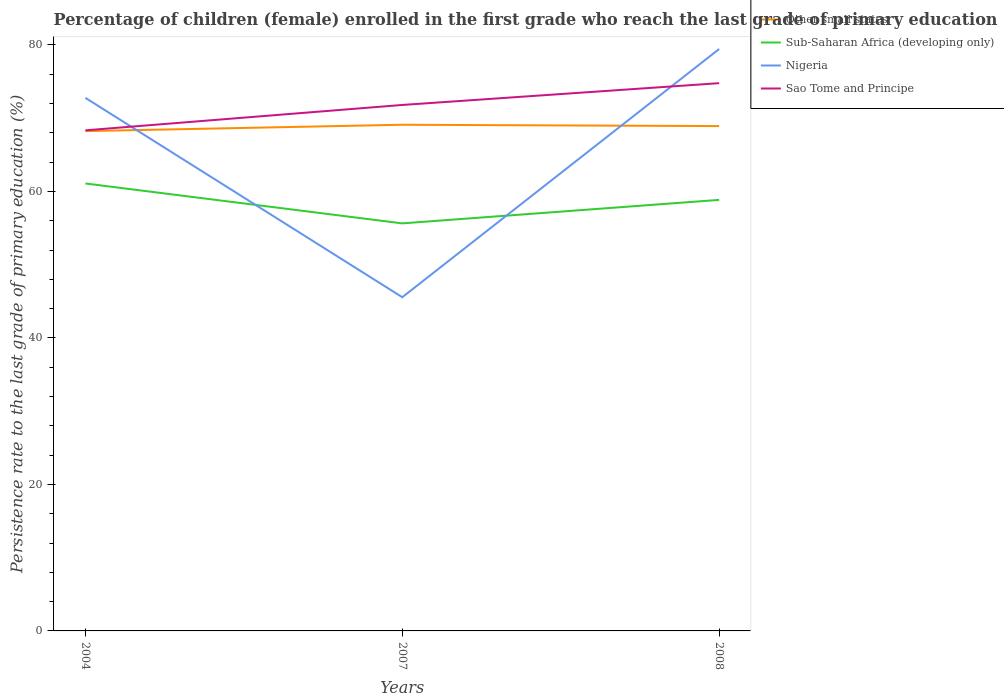Across all years, what is the maximum persistence rate of children in Sub-Saharan Africa (developing only)?
Give a very brief answer. 55.64. What is the total persistence rate of children in Sub-Saharan Africa (developing only) in the graph?
Provide a short and direct response. 5.45. What is the difference between the highest and the second highest persistence rate of children in Sao Tome and Principe?
Provide a short and direct response. 6.44. What is the difference between the highest and the lowest persistence rate of children in Sub-Saharan Africa (developing only)?
Offer a very short reply. 2. Is the persistence rate of children in Sub-Saharan Africa (developing only) strictly greater than the persistence rate of children in Nigeria over the years?
Keep it short and to the point. No. What is the difference between two consecutive major ticks on the Y-axis?
Your answer should be compact. 20. What is the title of the graph?
Your answer should be compact. Percentage of children (female) enrolled in the first grade who reach the last grade of primary education. Does "St. Lucia" appear as one of the legend labels in the graph?
Provide a short and direct response. No. What is the label or title of the X-axis?
Offer a terse response. Years. What is the label or title of the Y-axis?
Offer a very short reply. Persistence rate to the last grade of primary education (%). What is the Persistence rate to the last grade of primary education (%) of Other small states in 2004?
Give a very brief answer. 68.23. What is the Persistence rate to the last grade of primary education (%) of Sub-Saharan Africa (developing only) in 2004?
Give a very brief answer. 61.08. What is the Persistence rate to the last grade of primary education (%) in Nigeria in 2004?
Give a very brief answer. 72.77. What is the Persistence rate to the last grade of primary education (%) in Sao Tome and Principe in 2004?
Your answer should be very brief. 68.34. What is the Persistence rate to the last grade of primary education (%) of Other small states in 2007?
Keep it short and to the point. 69.1. What is the Persistence rate to the last grade of primary education (%) of Sub-Saharan Africa (developing only) in 2007?
Keep it short and to the point. 55.64. What is the Persistence rate to the last grade of primary education (%) of Nigeria in 2007?
Your answer should be very brief. 45.56. What is the Persistence rate to the last grade of primary education (%) in Sao Tome and Principe in 2007?
Your answer should be compact. 71.8. What is the Persistence rate to the last grade of primary education (%) in Other small states in 2008?
Offer a very short reply. 68.92. What is the Persistence rate to the last grade of primary education (%) of Sub-Saharan Africa (developing only) in 2008?
Provide a succinct answer. 58.85. What is the Persistence rate to the last grade of primary education (%) of Nigeria in 2008?
Provide a short and direct response. 79.44. What is the Persistence rate to the last grade of primary education (%) in Sao Tome and Principe in 2008?
Provide a short and direct response. 74.78. Across all years, what is the maximum Persistence rate to the last grade of primary education (%) in Other small states?
Offer a very short reply. 69.1. Across all years, what is the maximum Persistence rate to the last grade of primary education (%) of Sub-Saharan Africa (developing only)?
Provide a succinct answer. 61.08. Across all years, what is the maximum Persistence rate to the last grade of primary education (%) in Nigeria?
Make the answer very short. 79.44. Across all years, what is the maximum Persistence rate to the last grade of primary education (%) in Sao Tome and Principe?
Offer a terse response. 74.78. Across all years, what is the minimum Persistence rate to the last grade of primary education (%) in Other small states?
Your answer should be compact. 68.23. Across all years, what is the minimum Persistence rate to the last grade of primary education (%) in Sub-Saharan Africa (developing only)?
Offer a very short reply. 55.64. Across all years, what is the minimum Persistence rate to the last grade of primary education (%) of Nigeria?
Your response must be concise. 45.56. Across all years, what is the minimum Persistence rate to the last grade of primary education (%) of Sao Tome and Principe?
Offer a very short reply. 68.34. What is the total Persistence rate to the last grade of primary education (%) in Other small states in the graph?
Make the answer very short. 206.25. What is the total Persistence rate to the last grade of primary education (%) of Sub-Saharan Africa (developing only) in the graph?
Provide a succinct answer. 175.57. What is the total Persistence rate to the last grade of primary education (%) in Nigeria in the graph?
Your answer should be very brief. 197.77. What is the total Persistence rate to the last grade of primary education (%) in Sao Tome and Principe in the graph?
Your answer should be very brief. 214.93. What is the difference between the Persistence rate to the last grade of primary education (%) in Other small states in 2004 and that in 2007?
Provide a succinct answer. -0.87. What is the difference between the Persistence rate to the last grade of primary education (%) of Sub-Saharan Africa (developing only) in 2004 and that in 2007?
Your response must be concise. 5.45. What is the difference between the Persistence rate to the last grade of primary education (%) in Nigeria in 2004 and that in 2007?
Offer a terse response. 27.21. What is the difference between the Persistence rate to the last grade of primary education (%) of Sao Tome and Principe in 2004 and that in 2007?
Your response must be concise. -3.46. What is the difference between the Persistence rate to the last grade of primary education (%) of Other small states in 2004 and that in 2008?
Your response must be concise. -0.69. What is the difference between the Persistence rate to the last grade of primary education (%) of Sub-Saharan Africa (developing only) in 2004 and that in 2008?
Make the answer very short. 2.24. What is the difference between the Persistence rate to the last grade of primary education (%) in Nigeria in 2004 and that in 2008?
Make the answer very short. -6.67. What is the difference between the Persistence rate to the last grade of primary education (%) in Sao Tome and Principe in 2004 and that in 2008?
Ensure brevity in your answer.  -6.44. What is the difference between the Persistence rate to the last grade of primary education (%) of Other small states in 2007 and that in 2008?
Your answer should be compact. 0.18. What is the difference between the Persistence rate to the last grade of primary education (%) in Sub-Saharan Africa (developing only) in 2007 and that in 2008?
Give a very brief answer. -3.21. What is the difference between the Persistence rate to the last grade of primary education (%) in Nigeria in 2007 and that in 2008?
Make the answer very short. -33.89. What is the difference between the Persistence rate to the last grade of primary education (%) in Sao Tome and Principe in 2007 and that in 2008?
Ensure brevity in your answer.  -2.98. What is the difference between the Persistence rate to the last grade of primary education (%) in Other small states in 2004 and the Persistence rate to the last grade of primary education (%) in Sub-Saharan Africa (developing only) in 2007?
Give a very brief answer. 12.59. What is the difference between the Persistence rate to the last grade of primary education (%) in Other small states in 2004 and the Persistence rate to the last grade of primary education (%) in Nigeria in 2007?
Provide a succinct answer. 22.67. What is the difference between the Persistence rate to the last grade of primary education (%) in Other small states in 2004 and the Persistence rate to the last grade of primary education (%) in Sao Tome and Principe in 2007?
Keep it short and to the point. -3.57. What is the difference between the Persistence rate to the last grade of primary education (%) in Sub-Saharan Africa (developing only) in 2004 and the Persistence rate to the last grade of primary education (%) in Nigeria in 2007?
Make the answer very short. 15.53. What is the difference between the Persistence rate to the last grade of primary education (%) of Sub-Saharan Africa (developing only) in 2004 and the Persistence rate to the last grade of primary education (%) of Sao Tome and Principe in 2007?
Provide a short and direct response. -10.72. What is the difference between the Persistence rate to the last grade of primary education (%) in Nigeria in 2004 and the Persistence rate to the last grade of primary education (%) in Sao Tome and Principe in 2007?
Offer a very short reply. 0.97. What is the difference between the Persistence rate to the last grade of primary education (%) in Other small states in 2004 and the Persistence rate to the last grade of primary education (%) in Sub-Saharan Africa (developing only) in 2008?
Ensure brevity in your answer.  9.39. What is the difference between the Persistence rate to the last grade of primary education (%) in Other small states in 2004 and the Persistence rate to the last grade of primary education (%) in Nigeria in 2008?
Your answer should be compact. -11.21. What is the difference between the Persistence rate to the last grade of primary education (%) in Other small states in 2004 and the Persistence rate to the last grade of primary education (%) in Sao Tome and Principe in 2008?
Provide a short and direct response. -6.55. What is the difference between the Persistence rate to the last grade of primary education (%) of Sub-Saharan Africa (developing only) in 2004 and the Persistence rate to the last grade of primary education (%) of Nigeria in 2008?
Your answer should be compact. -18.36. What is the difference between the Persistence rate to the last grade of primary education (%) in Sub-Saharan Africa (developing only) in 2004 and the Persistence rate to the last grade of primary education (%) in Sao Tome and Principe in 2008?
Your response must be concise. -13.69. What is the difference between the Persistence rate to the last grade of primary education (%) in Nigeria in 2004 and the Persistence rate to the last grade of primary education (%) in Sao Tome and Principe in 2008?
Provide a short and direct response. -2.01. What is the difference between the Persistence rate to the last grade of primary education (%) in Other small states in 2007 and the Persistence rate to the last grade of primary education (%) in Sub-Saharan Africa (developing only) in 2008?
Offer a very short reply. 10.26. What is the difference between the Persistence rate to the last grade of primary education (%) in Other small states in 2007 and the Persistence rate to the last grade of primary education (%) in Nigeria in 2008?
Your response must be concise. -10.34. What is the difference between the Persistence rate to the last grade of primary education (%) in Other small states in 2007 and the Persistence rate to the last grade of primary education (%) in Sao Tome and Principe in 2008?
Make the answer very short. -5.68. What is the difference between the Persistence rate to the last grade of primary education (%) of Sub-Saharan Africa (developing only) in 2007 and the Persistence rate to the last grade of primary education (%) of Nigeria in 2008?
Your answer should be very brief. -23.81. What is the difference between the Persistence rate to the last grade of primary education (%) in Sub-Saharan Africa (developing only) in 2007 and the Persistence rate to the last grade of primary education (%) in Sao Tome and Principe in 2008?
Offer a terse response. -19.14. What is the difference between the Persistence rate to the last grade of primary education (%) in Nigeria in 2007 and the Persistence rate to the last grade of primary education (%) in Sao Tome and Principe in 2008?
Ensure brevity in your answer.  -29.22. What is the average Persistence rate to the last grade of primary education (%) of Other small states per year?
Keep it short and to the point. 68.75. What is the average Persistence rate to the last grade of primary education (%) of Sub-Saharan Africa (developing only) per year?
Keep it short and to the point. 58.52. What is the average Persistence rate to the last grade of primary education (%) in Nigeria per year?
Your response must be concise. 65.92. What is the average Persistence rate to the last grade of primary education (%) in Sao Tome and Principe per year?
Make the answer very short. 71.64. In the year 2004, what is the difference between the Persistence rate to the last grade of primary education (%) in Other small states and Persistence rate to the last grade of primary education (%) in Sub-Saharan Africa (developing only)?
Offer a terse response. 7.15. In the year 2004, what is the difference between the Persistence rate to the last grade of primary education (%) of Other small states and Persistence rate to the last grade of primary education (%) of Nigeria?
Give a very brief answer. -4.54. In the year 2004, what is the difference between the Persistence rate to the last grade of primary education (%) of Other small states and Persistence rate to the last grade of primary education (%) of Sao Tome and Principe?
Ensure brevity in your answer.  -0.11. In the year 2004, what is the difference between the Persistence rate to the last grade of primary education (%) of Sub-Saharan Africa (developing only) and Persistence rate to the last grade of primary education (%) of Nigeria?
Provide a succinct answer. -11.69. In the year 2004, what is the difference between the Persistence rate to the last grade of primary education (%) of Sub-Saharan Africa (developing only) and Persistence rate to the last grade of primary education (%) of Sao Tome and Principe?
Provide a short and direct response. -7.26. In the year 2004, what is the difference between the Persistence rate to the last grade of primary education (%) in Nigeria and Persistence rate to the last grade of primary education (%) in Sao Tome and Principe?
Your answer should be compact. 4.43. In the year 2007, what is the difference between the Persistence rate to the last grade of primary education (%) in Other small states and Persistence rate to the last grade of primary education (%) in Sub-Saharan Africa (developing only)?
Offer a very short reply. 13.46. In the year 2007, what is the difference between the Persistence rate to the last grade of primary education (%) in Other small states and Persistence rate to the last grade of primary education (%) in Nigeria?
Provide a succinct answer. 23.54. In the year 2007, what is the difference between the Persistence rate to the last grade of primary education (%) of Other small states and Persistence rate to the last grade of primary education (%) of Sao Tome and Principe?
Your answer should be very brief. -2.7. In the year 2007, what is the difference between the Persistence rate to the last grade of primary education (%) in Sub-Saharan Africa (developing only) and Persistence rate to the last grade of primary education (%) in Nigeria?
Provide a succinct answer. 10.08. In the year 2007, what is the difference between the Persistence rate to the last grade of primary education (%) in Sub-Saharan Africa (developing only) and Persistence rate to the last grade of primary education (%) in Sao Tome and Principe?
Make the answer very short. -16.17. In the year 2007, what is the difference between the Persistence rate to the last grade of primary education (%) in Nigeria and Persistence rate to the last grade of primary education (%) in Sao Tome and Principe?
Your response must be concise. -26.25. In the year 2008, what is the difference between the Persistence rate to the last grade of primary education (%) in Other small states and Persistence rate to the last grade of primary education (%) in Sub-Saharan Africa (developing only)?
Provide a short and direct response. 10.07. In the year 2008, what is the difference between the Persistence rate to the last grade of primary education (%) of Other small states and Persistence rate to the last grade of primary education (%) of Nigeria?
Your answer should be very brief. -10.53. In the year 2008, what is the difference between the Persistence rate to the last grade of primary education (%) in Other small states and Persistence rate to the last grade of primary education (%) in Sao Tome and Principe?
Give a very brief answer. -5.86. In the year 2008, what is the difference between the Persistence rate to the last grade of primary education (%) of Sub-Saharan Africa (developing only) and Persistence rate to the last grade of primary education (%) of Nigeria?
Your answer should be very brief. -20.6. In the year 2008, what is the difference between the Persistence rate to the last grade of primary education (%) in Sub-Saharan Africa (developing only) and Persistence rate to the last grade of primary education (%) in Sao Tome and Principe?
Keep it short and to the point. -15.93. In the year 2008, what is the difference between the Persistence rate to the last grade of primary education (%) in Nigeria and Persistence rate to the last grade of primary education (%) in Sao Tome and Principe?
Offer a very short reply. 4.67. What is the ratio of the Persistence rate to the last grade of primary education (%) of Other small states in 2004 to that in 2007?
Your answer should be compact. 0.99. What is the ratio of the Persistence rate to the last grade of primary education (%) in Sub-Saharan Africa (developing only) in 2004 to that in 2007?
Offer a terse response. 1.1. What is the ratio of the Persistence rate to the last grade of primary education (%) of Nigeria in 2004 to that in 2007?
Offer a terse response. 1.6. What is the ratio of the Persistence rate to the last grade of primary education (%) of Sao Tome and Principe in 2004 to that in 2007?
Provide a short and direct response. 0.95. What is the ratio of the Persistence rate to the last grade of primary education (%) of Sub-Saharan Africa (developing only) in 2004 to that in 2008?
Give a very brief answer. 1.04. What is the ratio of the Persistence rate to the last grade of primary education (%) in Nigeria in 2004 to that in 2008?
Your response must be concise. 0.92. What is the ratio of the Persistence rate to the last grade of primary education (%) of Sao Tome and Principe in 2004 to that in 2008?
Your answer should be compact. 0.91. What is the ratio of the Persistence rate to the last grade of primary education (%) of Sub-Saharan Africa (developing only) in 2007 to that in 2008?
Your answer should be very brief. 0.95. What is the ratio of the Persistence rate to the last grade of primary education (%) in Nigeria in 2007 to that in 2008?
Provide a succinct answer. 0.57. What is the ratio of the Persistence rate to the last grade of primary education (%) of Sao Tome and Principe in 2007 to that in 2008?
Make the answer very short. 0.96. What is the difference between the highest and the second highest Persistence rate to the last grade of primary education (%) in Other small states?
Give a very brief answer. 0.18. What is the difference between the highest and the second highest Persistence rate to the last grade of primary education (%) in Sub-Saharan Africa (developing only)?
Your response must be concise. 2.24. What is the difference between the highest and the second highest Persistence rate to the last grade of primary education (%) of Nigeria?
Ensure brevity in your answer.  6.67. What is the difference between the highest and the second highest Persistence rate to the last grade of primary education (%) in Sao Tome and Principe?
Provide a short and direct response. 2.98. What is the difference between the highest and the lowest Persistence rate to the last grade of primary education (%) of Other small states?
Ensure brevity in your answer.  0.87. What is the difference between the highest and the lowest Persistence rate to the last grade of primary education (%) in Sub-Saharan Africa (developing only)?
Make the answer very short. 5.45. What is the difference between the highest and the lowest Persistence rate to the last grade of primary education (%) in Nigeria?
Provide a succinct answer. 33.89. What is the difference between the highest and the lowest Persistence rate to the last grade of primary education (%) of Sao Tome and Principe?
Give a very brief answer. 6.44. 